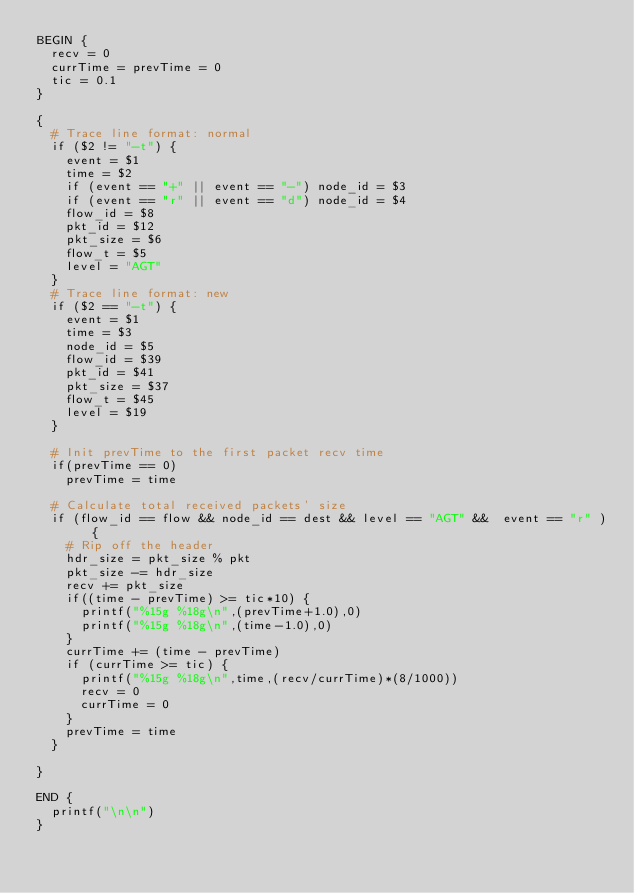Convert code to text. <code><loc_0><loc_0><loc_500><loc_500><_Awk_>BEGIN {
	recv = 0
	currTime = prevTime = 0
	tic = 0.1
}

{
	# Trace line format: normal
	if ($2 != "-t") {
		event = $1
		time = $2
		if (event == "+" || event == "-") node_id = $3
		if (event == "r" || event == "d") node_id = $4
		flow_id = $8
		pkt_id = $12
		pkt_size = $6
		flow_t = $5
		level = "AGT"
	}
	# Trace line format: new
	if ($2 == "-t") {
		event = $1
		time = $3
		node_id = $5
		flow_id = $39
		pkt_id = $41
		pkt_size = $37
		flow_t = $45
		level = $19
	}

	# Init prevTime to the first packet recv time
	if(prevTime == 0)
		prevTime = time

	# Calculate total received packets' size
	if (flow_id == flow && node_id == dest && level == "AGT" &&  event == "r" ) {
		# Rip off the header
		hdr_size = pkt_size % pkt
		pkt_size -= hdr_size
		recv += pkt_size
		if((time - prevTime) >= tic*10) {
			printf("%15g %18g\n",(prevTime+1.0),0)
			printf("%15g %18g\n",(time-1.0),0)
		}
		currTime += (time - prevTime)
		if (currTime >= tic) {
			printf("%15g %18g\n",time,(recv/currTime)*(8/1000))
			recv = 0
			currTime = 0
		}
		prevTime = time
	}

}

END {
	printf("\n\n")
}
</code> 